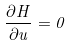Convert formula to latex. <formula><loc_0><loc_0><loc_500><loc_500>\frac { \partial H } { \partial u } = 0</formula> 